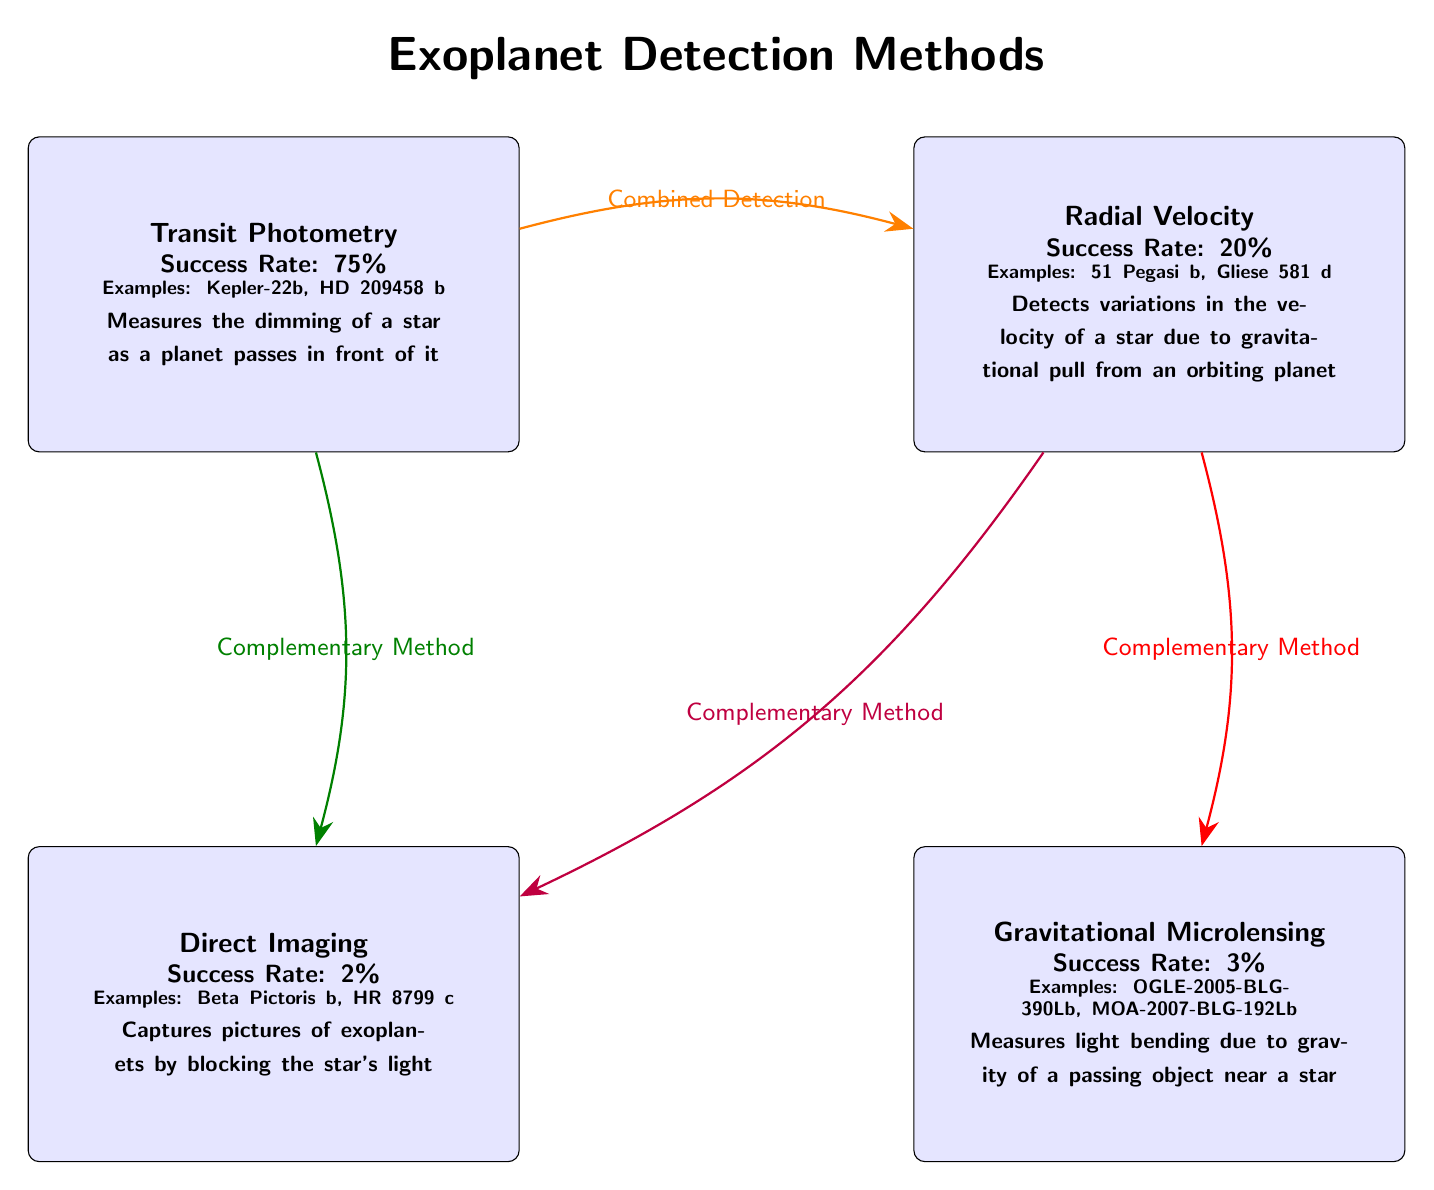What is the success rate of Transit Photometry? The diagram specifies a success rate of 75% next to the Transit Photometry node. This is a direct retrieval from the information presented in that specific node.
Answer: 75% What example discoveries are listed for Radial Velocity? According to the diagram, the examples listed for Radial Velocity are 51 Pegasi b and Gliese 581 d. This information comes directly from the Radial Velocity method node.
Answer: 51 Pegasi b, Gliese 581 d How many detection methods are represented in the diagram? The diagram shows a total of four distinct detection methods: Transit Photometry, Radial Velocity, Direct Imaging, and Gravitational Microlensing. By counting these methods, we arrive at the total.
Answer: 4 Which method has the highest success rate? By examining the success rates listed for each method, Transit Photometry at 75% is the highest compared to the others (20%, 2%, and 3% for the respective other methods). This involves comparing the numerical success rates across all methods.
Answer: Transit Photometry What types of relationships are shown between Transit Photometry and Direct Imaging? The diagram indicates a 'Complementary Method' relationship from Transit Photometry to Direct Imaging. This is shown by the arrow connecting the two nodes with the label stating the relationship type.
Answer: Complementary Method What is the success rate of Gravitational Microlensing? The Gravitational Microlensing node directly states a success rate of 3%. This is a straightforward retrieval from the details provided in that node.
Answer: 3% Which detection method has the least success rate? By comparing the success rates of all methods displayed in the diagram, Direct Imaging at 2% has the lowest success rate. A careful evaluation of each listed success rate leads to this conclusion.
Answer: Direct Imaging What is the significance of the arrows connecting the methods? The arrows connecting the methods represent relationships such as 'Combined Detection' or 'Complementary Method' between the different techniques, indicating how methods can support or enhance each other in the detection of exoplanets. Observing the labeled arrows provides this contextual information.
Answer: Relationships between methods Which detection method has two example discoveries listed? The diagram shows that both Transit Photometry and Radial Velocity list two example discoveries each (Kepler-22b, HD 209458 b for Transit; 51 Pegasi b, Gliese 581 d for Radial). This is derived from the example details presented in the respective nodes.
Answer: Two methods: Transit Photometry, Radial Velocity 